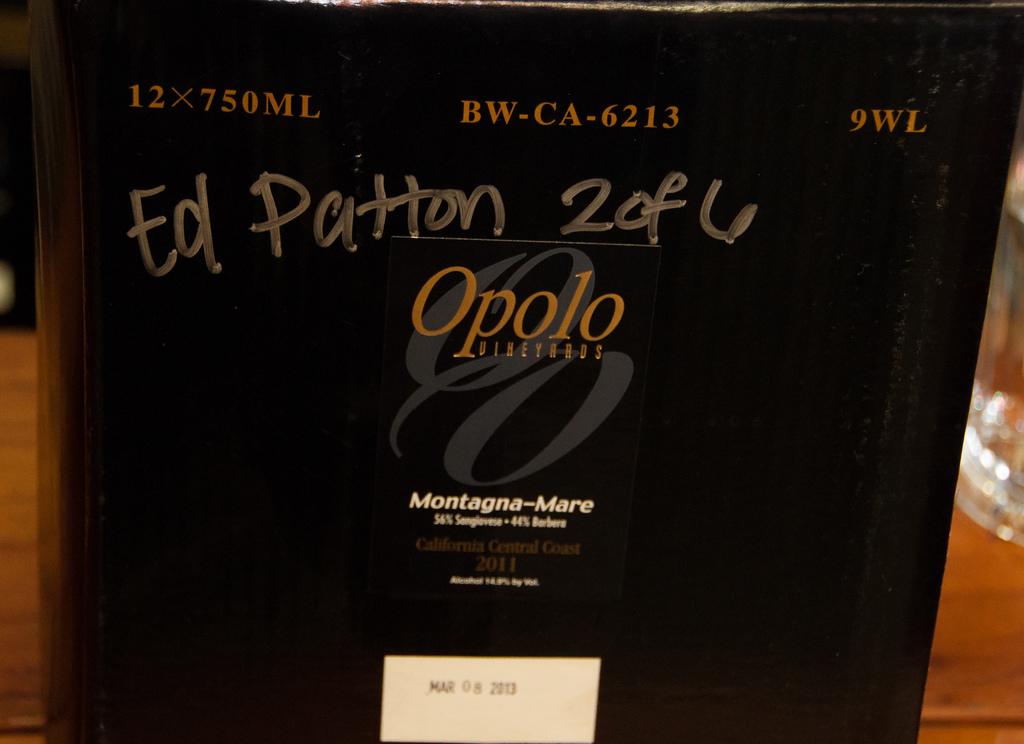What kind of wine is it?
Keep it short and to the point. Montagna-mare. 